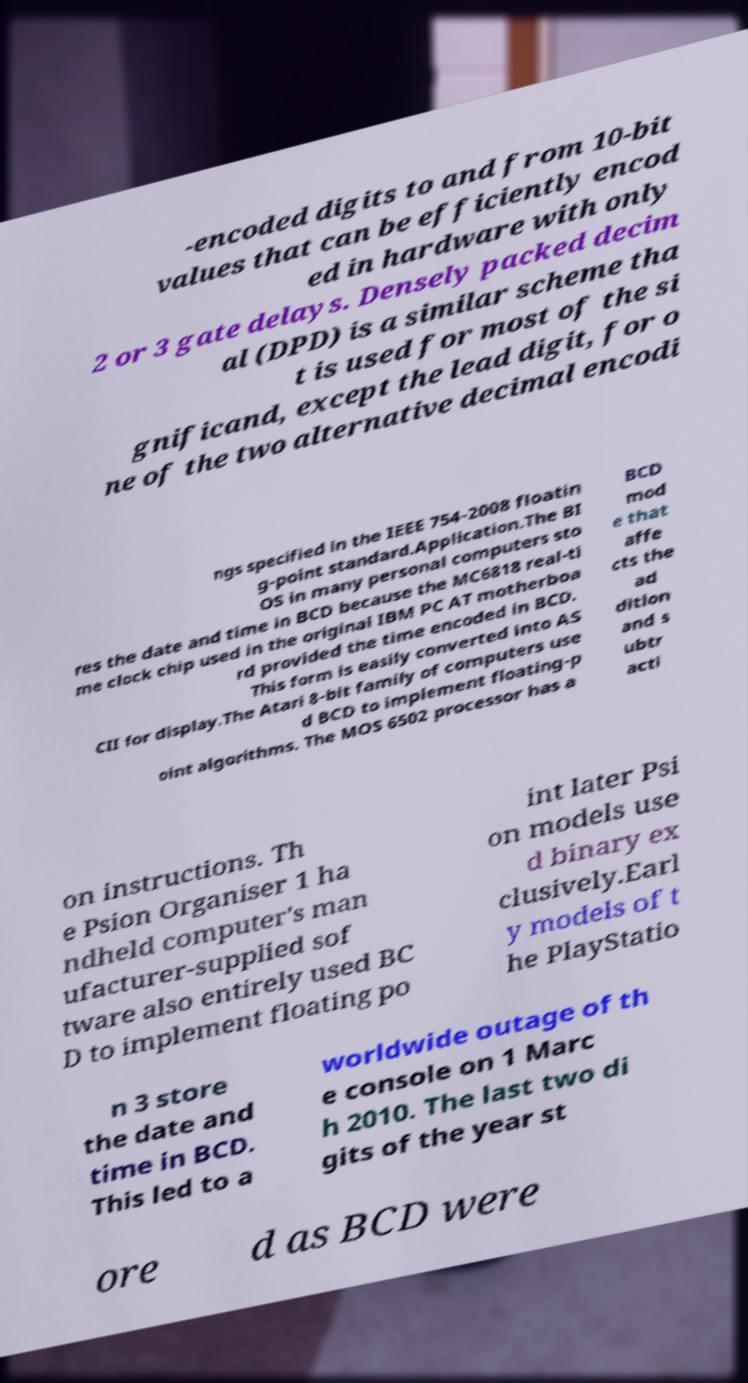Could you assist in decoding the text presented in this image and type it out clearly? -encoded digits to and from 10-bit values that can be efficiently encod ed in hardware with only 2 or 3 gate delays. Densely packed decim al (DPD) is a similar scheme tha t is used for most of the si gnificand, except the lead digit, for o ne of the two alternative decimal encodi ngs specified in the IEEE 754-2008 floatin g-point standard.Application.The BI OS in many personal computers sto res the date and time in BCD because the MC6818 real-ti me clock chip used in the original IBM PC AT motherboa rd provided the time encoded in BCD. This form is easily converted into AS CII for display.The Atari 8-bit family of computers use d BCD to implement floating-p oint algorithms. The MOS 6502 processor has a BCD mod e that affe cts the ad dition and s ubtr acti on instructions. Th e Psion Organiser 1 ha ndheld computer's man ufacturer-supplied sof tware also entirely used BC D to implement floating po int later Psi on models use d binary ex clusively.Earl y models of t he PlayStatio n 3 store the date and time in BCD. This led to a worldwide outage of th e console on 1 Marc h 2010. The last two di gits of the year st ore d as BCD were 